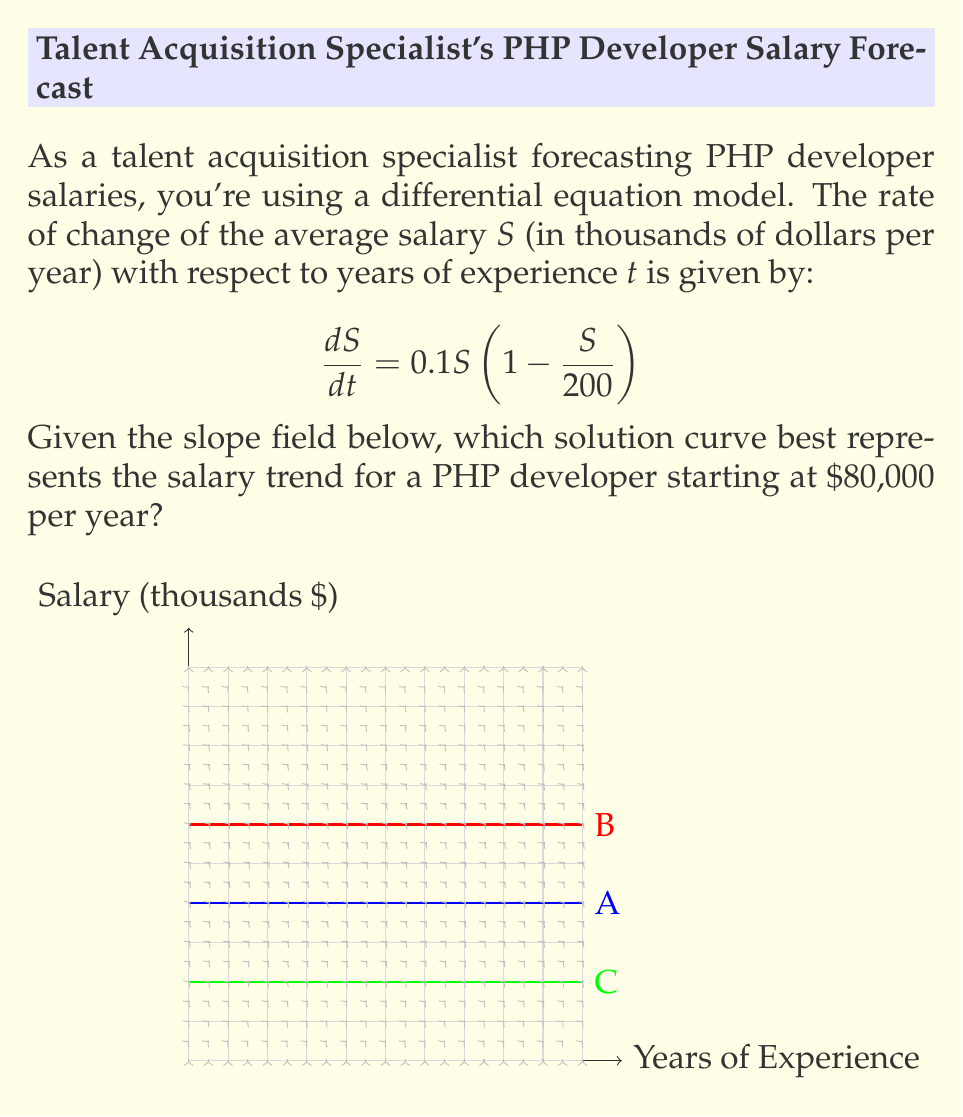Provide a solution to this math problem. To determine the correct solution curve, we need to analyze the given differential equation and slope field:

1) The differential equation $\frac{dS}{dt} = 0.1S(1 - \frac{S}{200})$ is a logistic growth model with a carrying capacity of $200,000.

2) In the slope field, the arrows represent the direction and magnitude of $\frac{dS}{dt}$ at each point.

3) The initial condition is $S(0) = 80$ (starting salary of $80,000).

4) Analyzing the three curves:
   A (Blue): Starts at $80,000 and approaches $200,000 asymptotically.
   B (Red): Starts at $120,000 and approaches $200,000 asymptotically.
   C (Green): Starts at $40,000 and approaches $200,000 asymptotically.

5) The blue curve (A) matches our initial condition of $80,000.

6) Following the slope field from the point (0, 80), we can see that the arrows align with the blue curve.

7) The blue curve also exhibits the expected behavior of the logistic model:
   - Rapid growth initially
   - Slowing down as it approaches the carrying capacity of $200,000

Therefore, the blue curve (A) best represents the salary trend for a PHP developer starting at $80,000 per year.
Answer: A (Blue curve) 